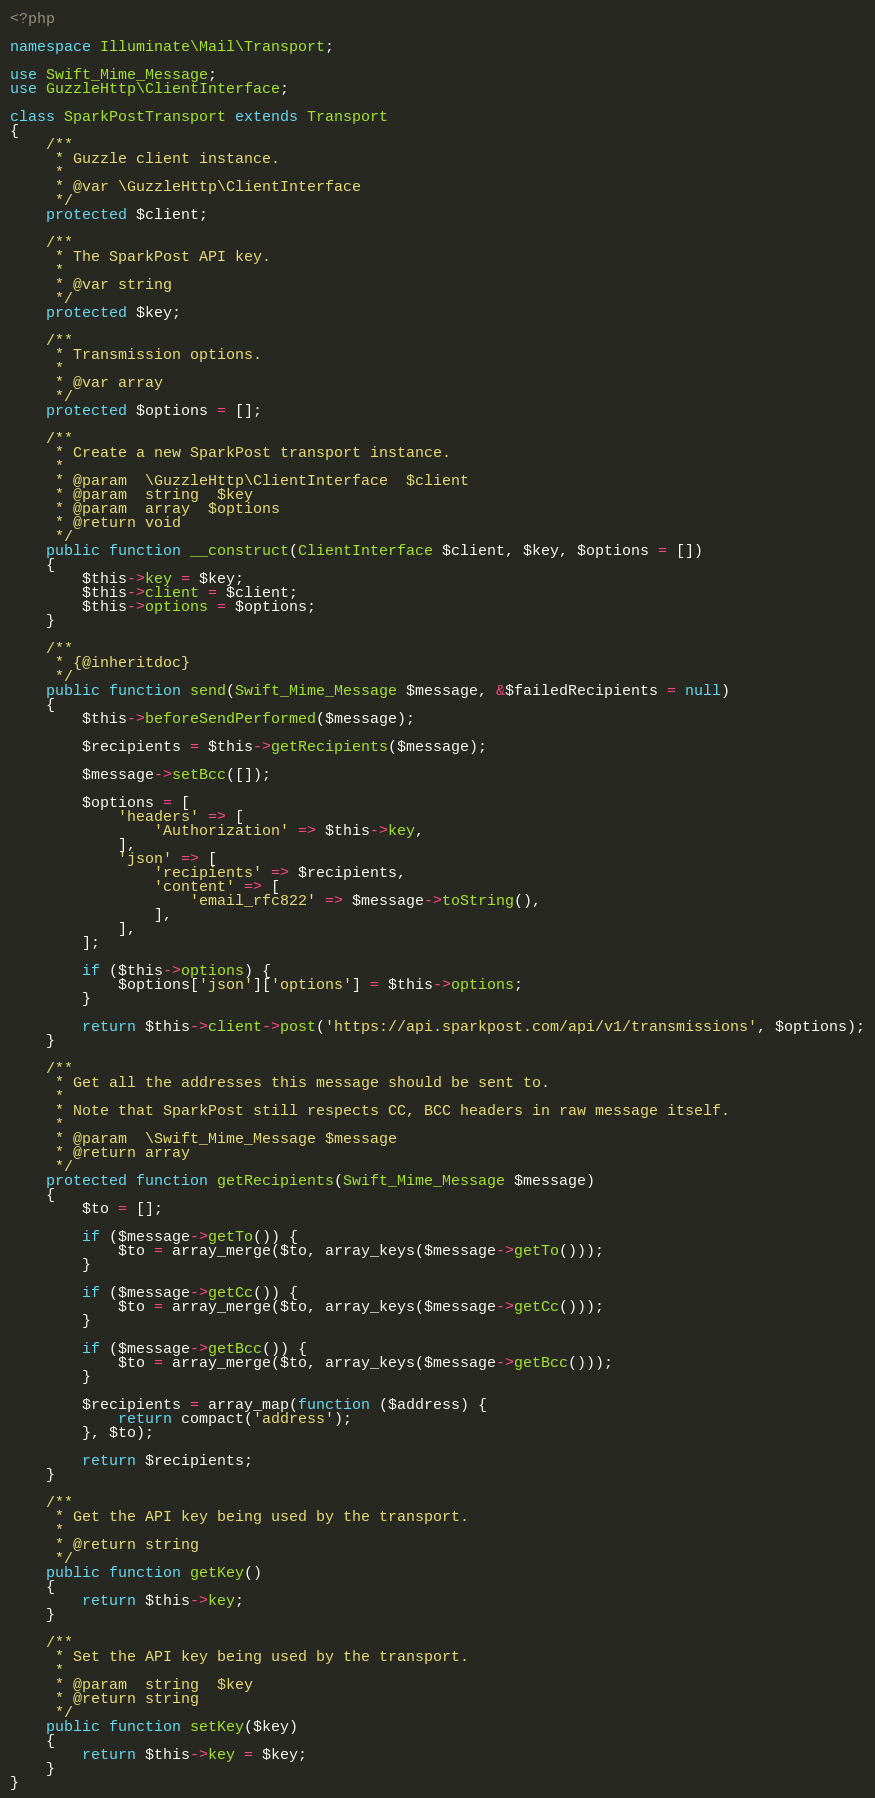Convert code to text. <code><loc_0><loc_0><loc_500><loc_500><_PHP_><?php

namespace Illuminate\Mail\Transport;

use Swift_Mime_Message;
use GuzzleHttp\ClientInterface;

class SparkPostTransport extends Transport
{
    /**
     * Guzzle client instance.
     *
     * @var \GuzzleHttp\ClientInterface
     */
    protected $client;

    /**
     * The SparkPost API key.
     *
     * @var string
     */
    protected $key;

    /**
     * Transmission options.
     *
     * @var array
     */
    protected $options = [];

    /**
     * Create a new SparkPost transport instance.
     *
     * @param  \GuzzleHttp\ClientInterface  $client
     * @param  string  $key
     * @param  array  $options
     * @return void
     */
    public function __construct(ClientInterface $client, $key, $options = [])
    {
        $this->key = $key;
        $this->client = $client;
        $this->options = $options;
    }

    /**
     * {@inheritdoc}
     */
    public function send(Swift_Mime_Message $message, &$failedRecipients = null)
    {
        $this->beforeSendPerformed($message);

        $recipients = $this->getRecipients($message);

        $message->setBcc([]);

        $options = [
            'headers' => [
                'Authorization' => $this->key,
            ],
            'json' => [
                'recipients' => $recipients,
                'content' => [
                    'email_rfc822' => $message->toString(),
                ],
            ],
        ];

        if ($this->options) {
            $options['json']['options'] = $this->options;
        }

        return $this->client->post('https://api.sparkpost.com/api/v1/transmissions', $options);
    }

    /**
     * Get all the addresses this message should be sent to.
     *
     * Note that SparkPost still respects CC, BCC headers in raw message itself.
     *
     * @param  \Swift_Mime_Message $message
     * @return array
     */
    protected function getRecipients(Swift_Mime_Message $message)
    {
        $to = [];

        if ($message->getTo()) {
            $to = array_merge($to, array_keys($message->getTo()));
        }

        if ($message->getCc()) {
            $to = array_merge($to, array_keys($message->getCc()));
        }

        if ($message->getBcc()) {
            $to = array_merge($to, array_keys($message->getBcc()));
        }

        $recipients = array_map(function ($address) {
            return compact('address');
        }, $to);

        return $recipients;
    }

    /**
     * Get the API key being used by the transport.
     *
     * @return string
     */
    public function getKey()
    {
        return $this->key;
    }

    /**
     * Set the API key being used by the transport.
     *
     * @param  string  $key
     * @return string
     */
    public function setKey($key)
    {
        return $this->key = $key;
    }
}
</code> 